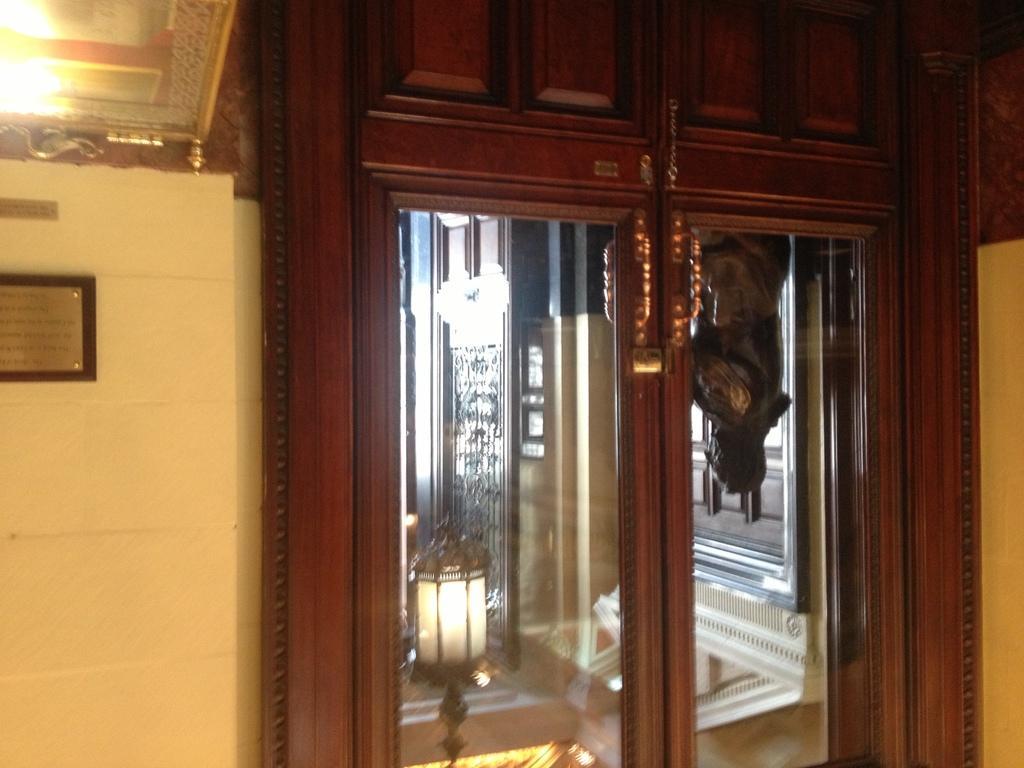In one or two sentences, can you explain what this image depicts? This is a picture taken in a room. On the left there is a frame and a wall. In the center of the picture there is it closet and mirror, in the mirror we can see lamp and a statue. 